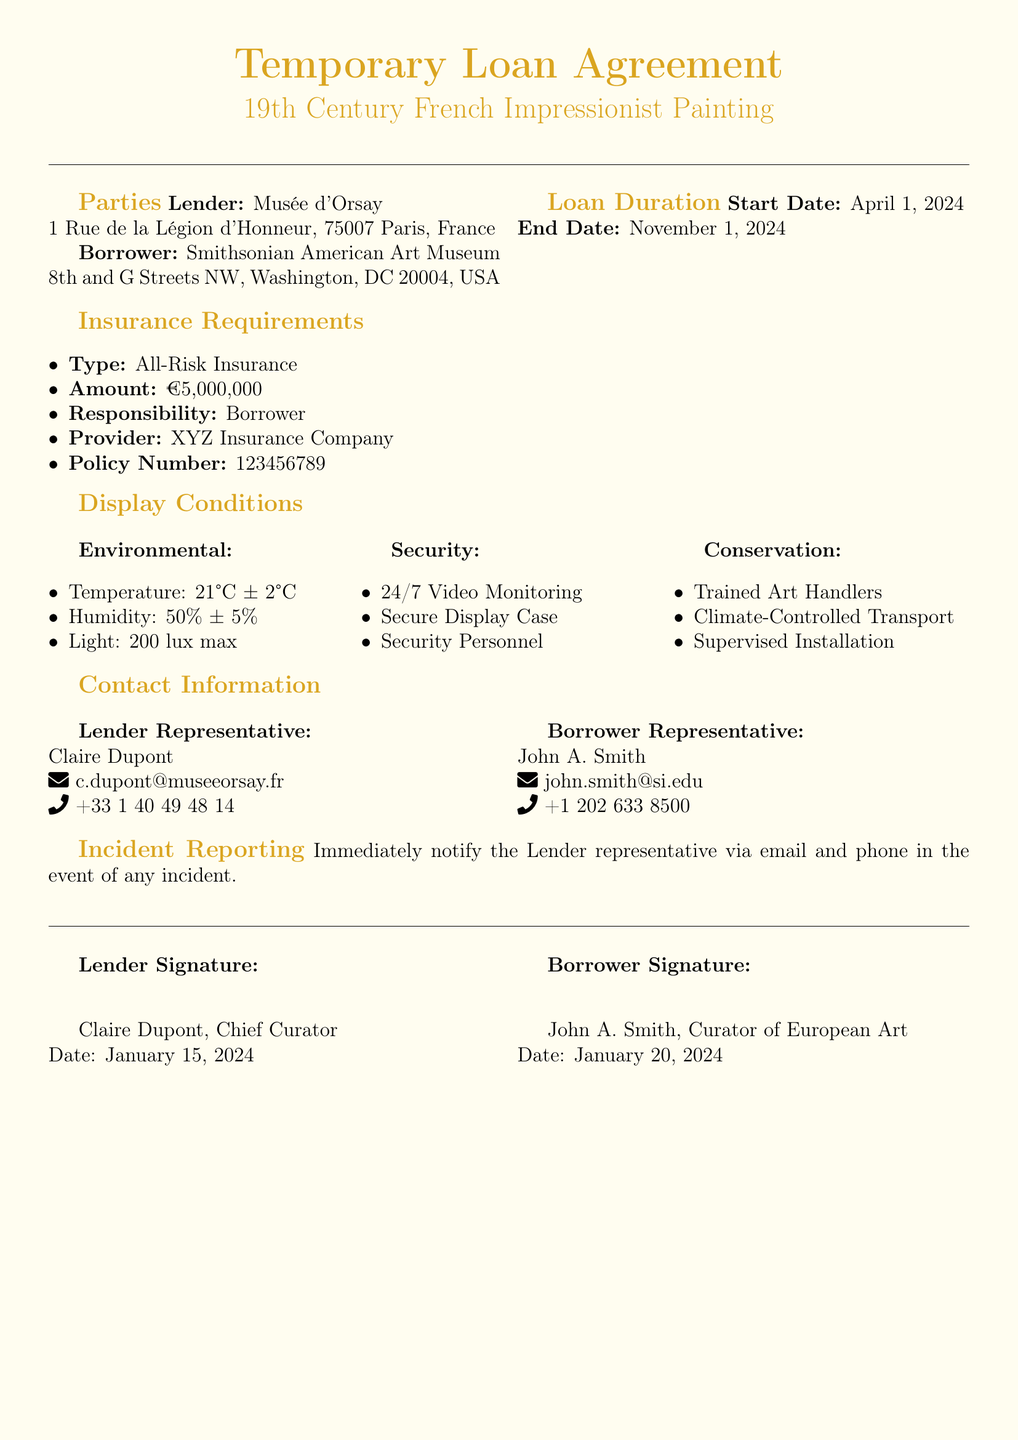What is the name of the lender? The lender's name is specified in the document under the Parties section, which states "Musée d'Orsay."
Answer: Musée d'Orsay What is the start date of the loan? The document states the start date under Loan Duration, which is "April 1, 2024."
Answer: April 1, 2024 What is the required insurance amount? The insurance requirements section indicates the amount, which is "€5,000,000."
Answer: €5,000,000 What is the humidity condition for display? The Display Conditions section specifies humidity requirements, stating "50% ± 5%."
Answer: 50% ± 5% Who is responsible for the insurance? The document outlines the party responsible for insurance in the Insurance Requirements section, which says "Borrower."
Answer: Borrower What is the maximum light level allowed? The light condition is explicitly mentioned under Display Conditions, stating "200 lux max."
Answer: 200 lux max What is the name of the borrower representative? The Borrower Representative's name is provided in the Contact Information section, which states "John A. Smith."
Answer: John A. Smith What type of insurance is required? The type of insurance is listed under the Insurance Requirements section, which notes "All-Risk Insurance."
Answer: All-Risk Insurance How many months is the loan duration? The loan period specified in the document lasts from April 1, 2024, to November 1, 2024, totaling 7 months.
Answer: 7 months 